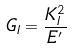Convert formula to latex. <formula><loc_0><loc_0><loc_500><loc_500>G _ { I } = \frac { K _ { I } ^ { 2 } } { E ^ { \prime } }</formula> 